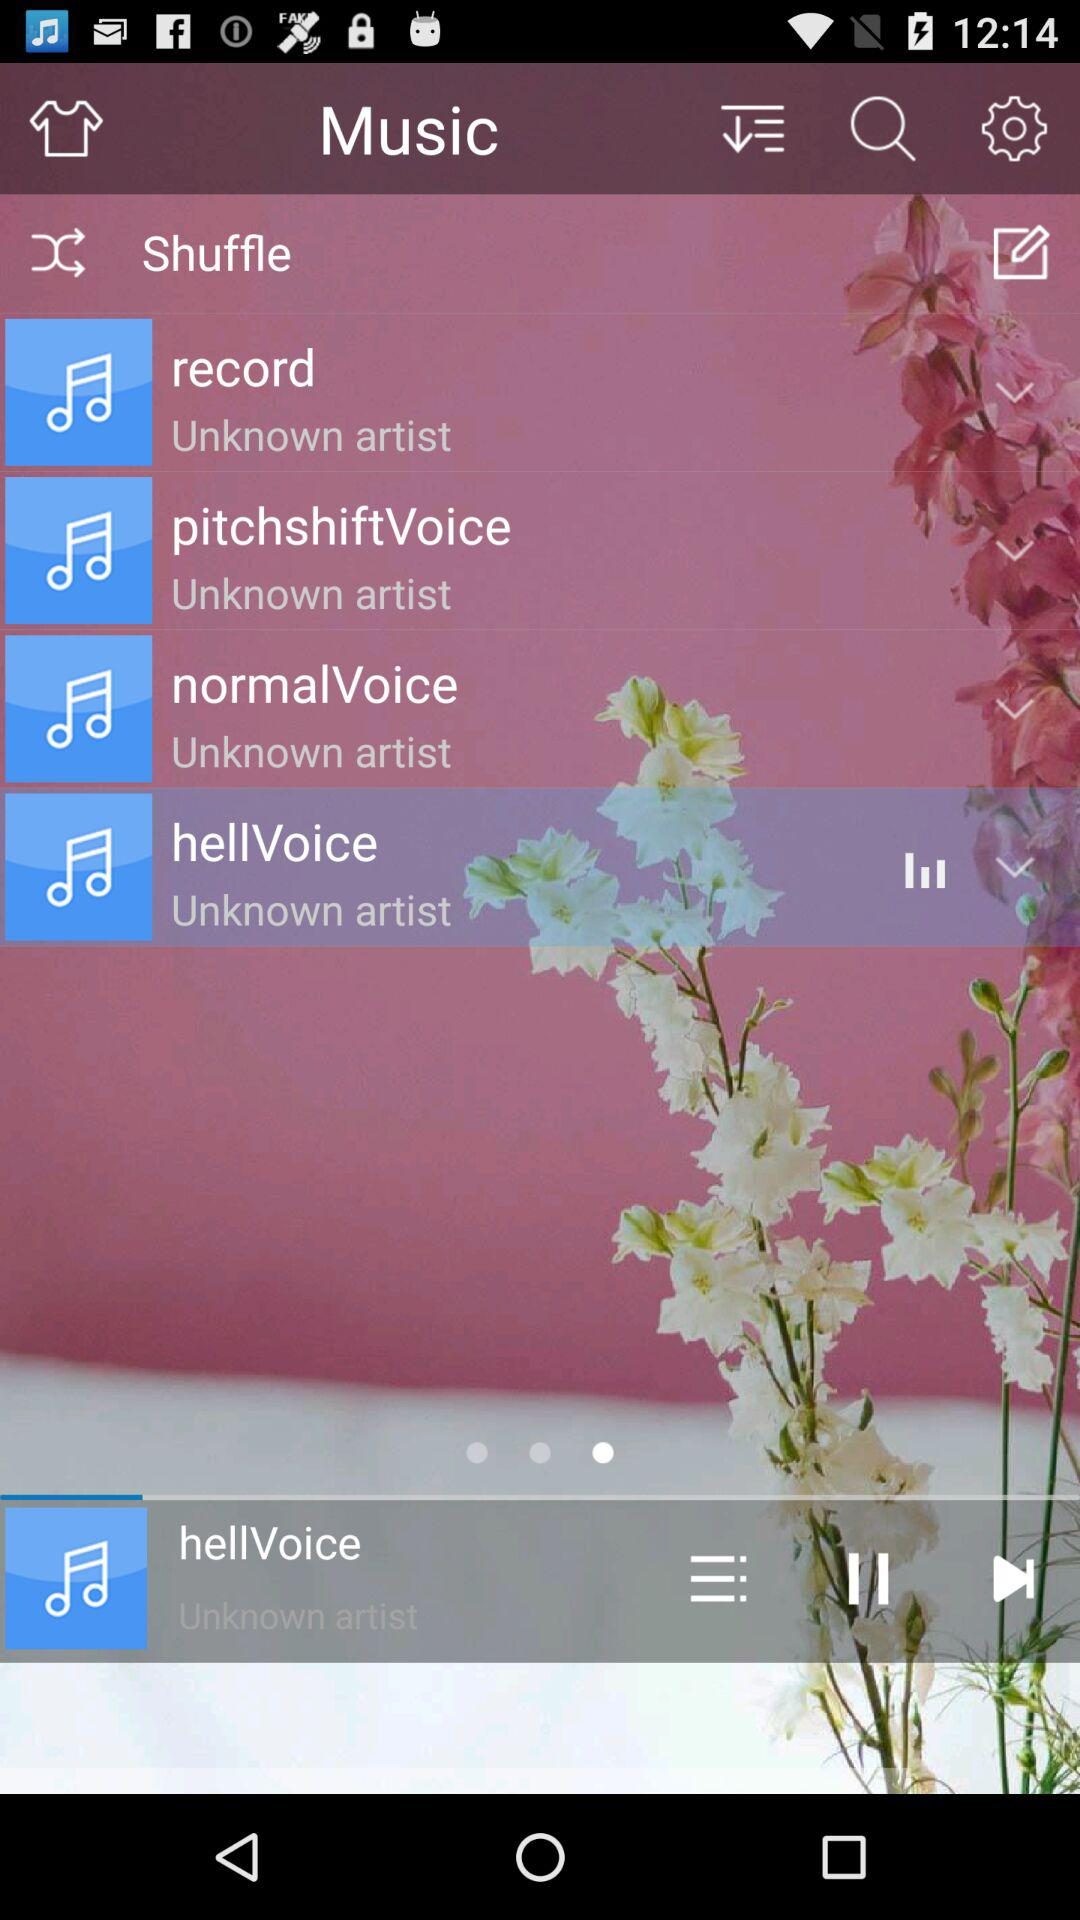Which music is currently playing? The currently playing music is "hellVoice". 